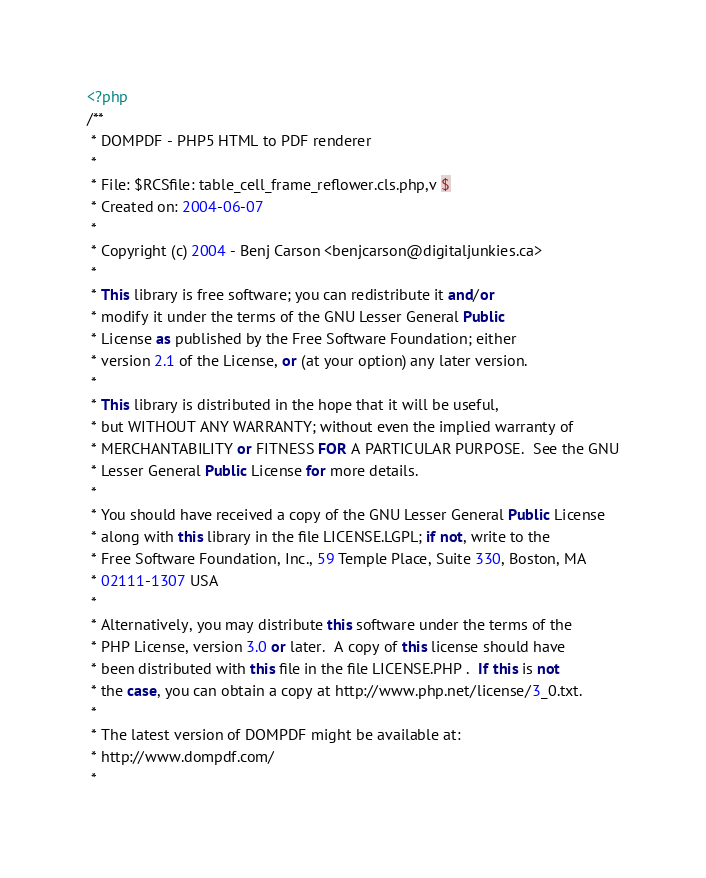<code> <loc_0><loc_0><loc_500><loc_500><_PHP_><?php
/**
 * DOMPDF - PHP5 HTML to PDF renderer
 *
 * File: $RCSfile: table_cell_frame_reflower.cls.php,v $
 * Created on: 2004-06-07
 *
 * Copyright (c) 2004 - Benj Carson <benjcarson@digitaljunkies.ca>
 *
 * This library is free software; you can redistribute it and/or
 * modify it under the terms of the GNU Lesser General Public
 * License as published by the Free Software Foundation; either
 * version 2.1 of the License, or (at your option) any later version.
 *
 * This library is distributed in the hope that it will be useful,
 * but WITHOUT ANY WARRANTY; without even the implied warranty of
 * MERCHANTABILITY or FITNESS FOR A PARTICULAR PURPOSE.  See the GNU
 * Lesser General Public License for more details.
 *
 * You should have received a copy of the GNU Lesser General Public License
 * along with this library in the file LICENSE.LGPL; if not, write to the
 * Free Software Foundation, Inc., 59 Temple Place, Suite 330, Boston, MA
 * 02111-1307 USA
 *
 * Alternatively, you may distribute this software under the terms of the
 * PHP License, version 3.0 or later.  A copy of this license should have
 * been distributed with this file in the file LICENSE.PHP .  If this is not
 * the case, you can obtain a copy at http://www.php.net/license/3_0.txt.
 *
 * The latest version of DOMPDF might be available at:
 * http://www.dompdf.com/
 *</code> 